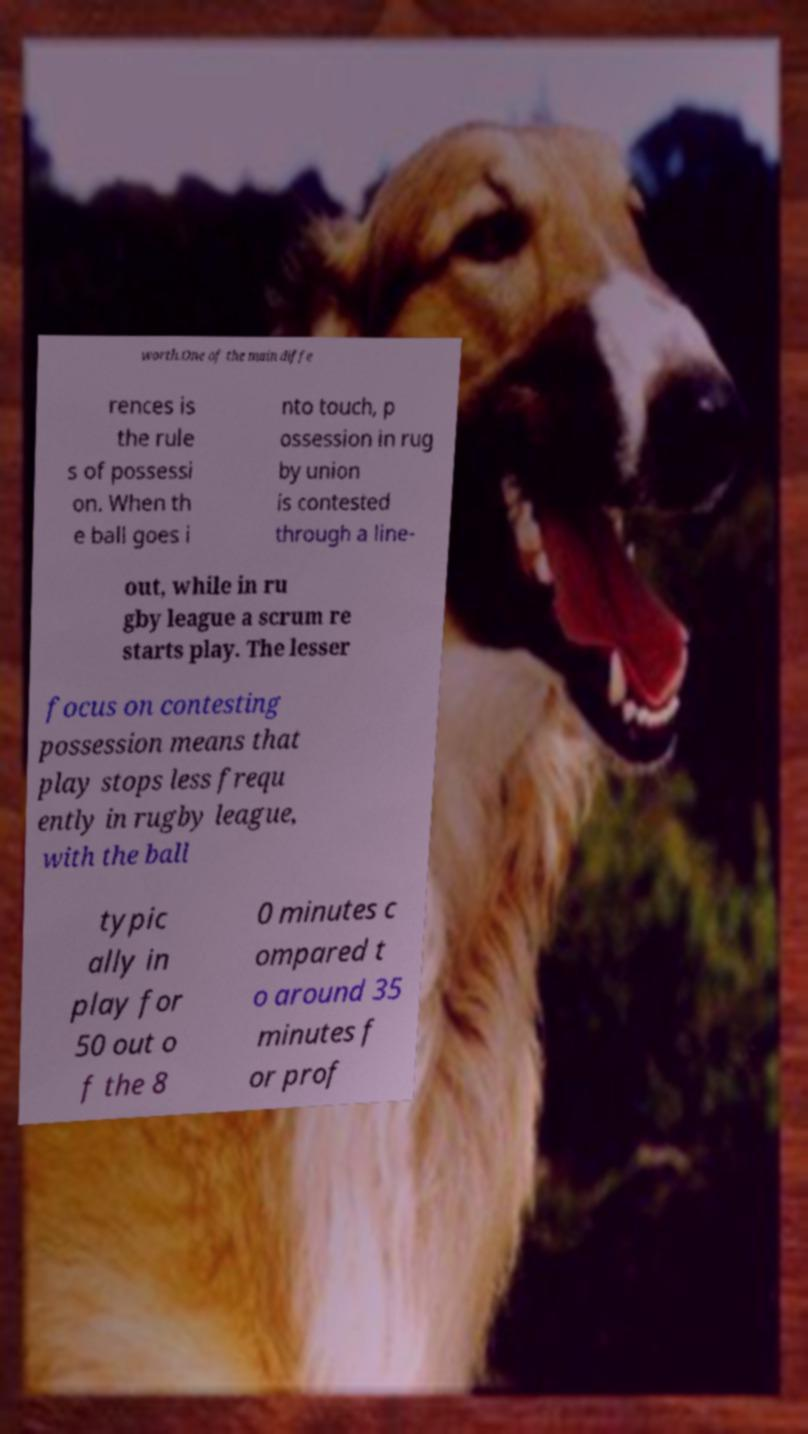There's text embedded in this image that I need extracted. Can you transcribe it verbatim? worth.One of the main diffe rences is the rule s of possessi on. When th e ball goes i nto touch, p ossession in rug by union is contested through a line- out, while in ru gby league a scrum re starts play. The lesser focus on contesting possession means that play stops less frequ ently in rugby league, with the ball typic ally in play for 50 out o f the 8 0 minutes c ompared t o around 35 minutes f or prof 